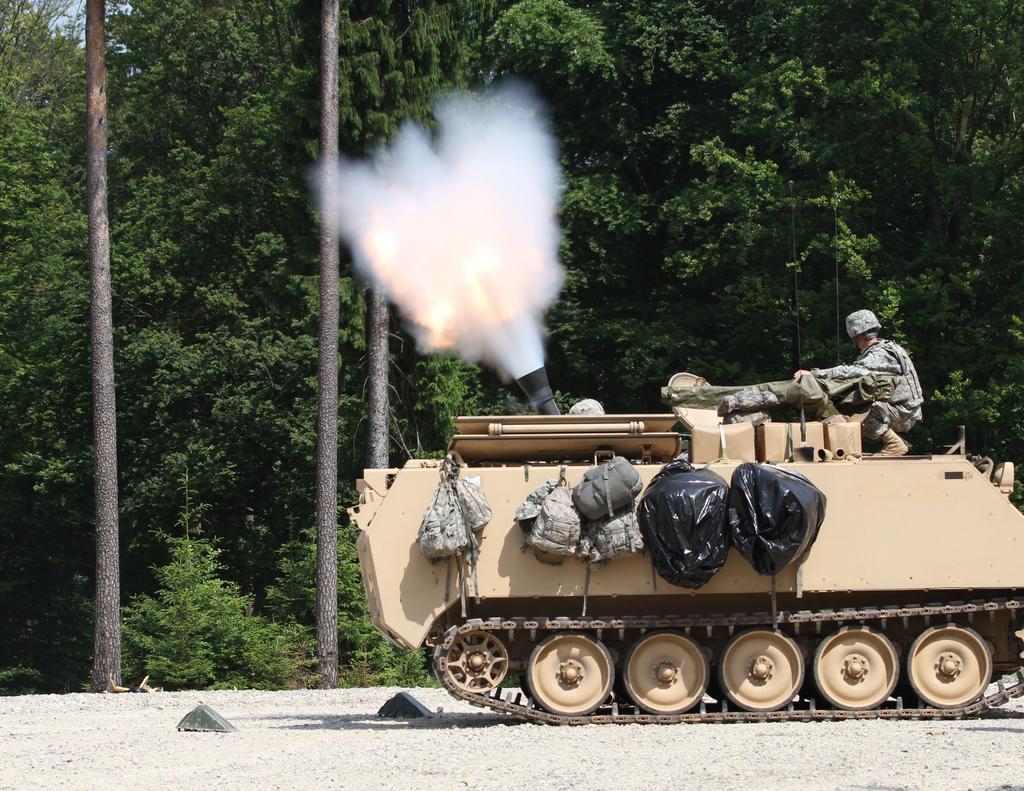Can you describe this image briefly? On the right side of the image we can see a man is driving a vehicle and also we can see the smoke, bags. In the background of the image we can see the trees. At the bottom of the image we can see the ground. 